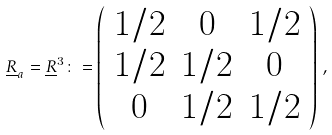<formula> <loc_0><loc_0><loc_500><loc_500>\underline { R } _ { a } = \underline { R } ^ { 3 } \colon = \left ( \begin{array} { c c c } 1 / 2 & 0 & 1 / 2 \\ 1 / 2 & 1 / 2 & 0 \\ 0 & 1 / 2 & 1 / 2 \end{array} \right ) \, ,</formula> 